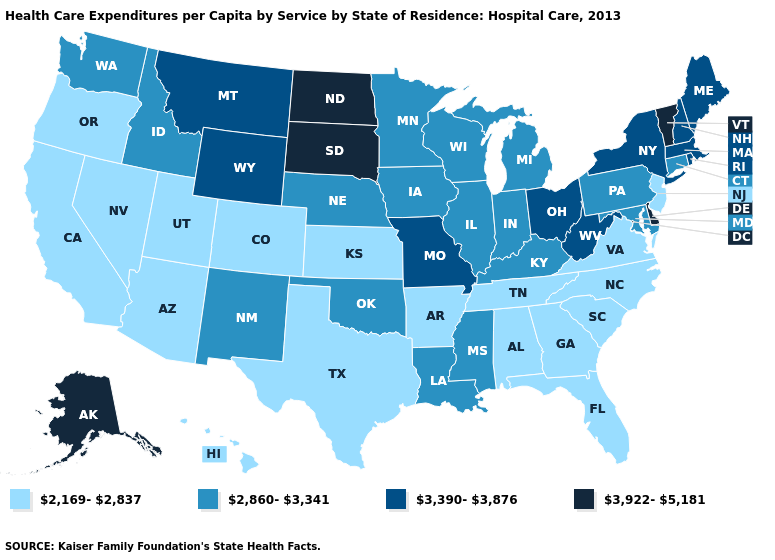What is the highest value in the Northeast ?
Quick response, please. 3,922-5,181. Name the states that have a value in the range 3,922-5,181?
Answer briefly. Alaska, Delaware, North Dakota, South Dakota, Vermont. What is the value of Indiana?
Quick response, please. 2,860-3,341. Name the states that have a value in the range 3,922-5,181?
Give a very brief answer. Alaska, Delaware, North Dakota, South Dakota, Vermont. Name the states that have a value in the range 2,169-2,837?
Give a very brief answer. Alabama, Arizona, Arkansas, California, Colorado, Florida, Georgia, Hawaii, Kansas, Nevada, New Jersey, North Carolina, Oregon, South Carolina, Tennessee, Texas, Utah, Virginia. What is the value of New Hampshire?
Short answer required. 3,390-3,876. What is the highest value in the South ?
Give a very brief answer. 3,922-5,181. What is the value of Maryland?
Short answer required. 2,860-3,341. Name the states that have a value in the range 3,390-3,876?
Write a very short answer. Maine, Massachusetts, Missouri, Montana, New Hampshire, New York, Ohio, Rhode Island, West Virginia, Wyoming. Name the states that have a value in the range 3,922-5,181?
Give a very brief answer. Alaska, Delaware, North Dakota, South Dakota, Vermont. How many symbols are there in the legend?
Short answer required. 4. Name the states that have a value in the range 2,169-2,837?
Write a very short answer. Alabama, Arizona, Arkansas, California, Colorado, Florida, Georgia, Hawaii, Kansas, Nevada, New Jersey, North Carolina, Oregon, South Carolina, Tennessee, Texas, Utah, Virginia. Does Wisconsin have a lower value than Missouri?
Concise answer only. Yes. Among the states that border Ohio , which have the lowest value?
Short answer required. Indiana, Kentucky, Michigan, Pennsylvania. How many symbols are there in the legend?
Be succinct. 4. 